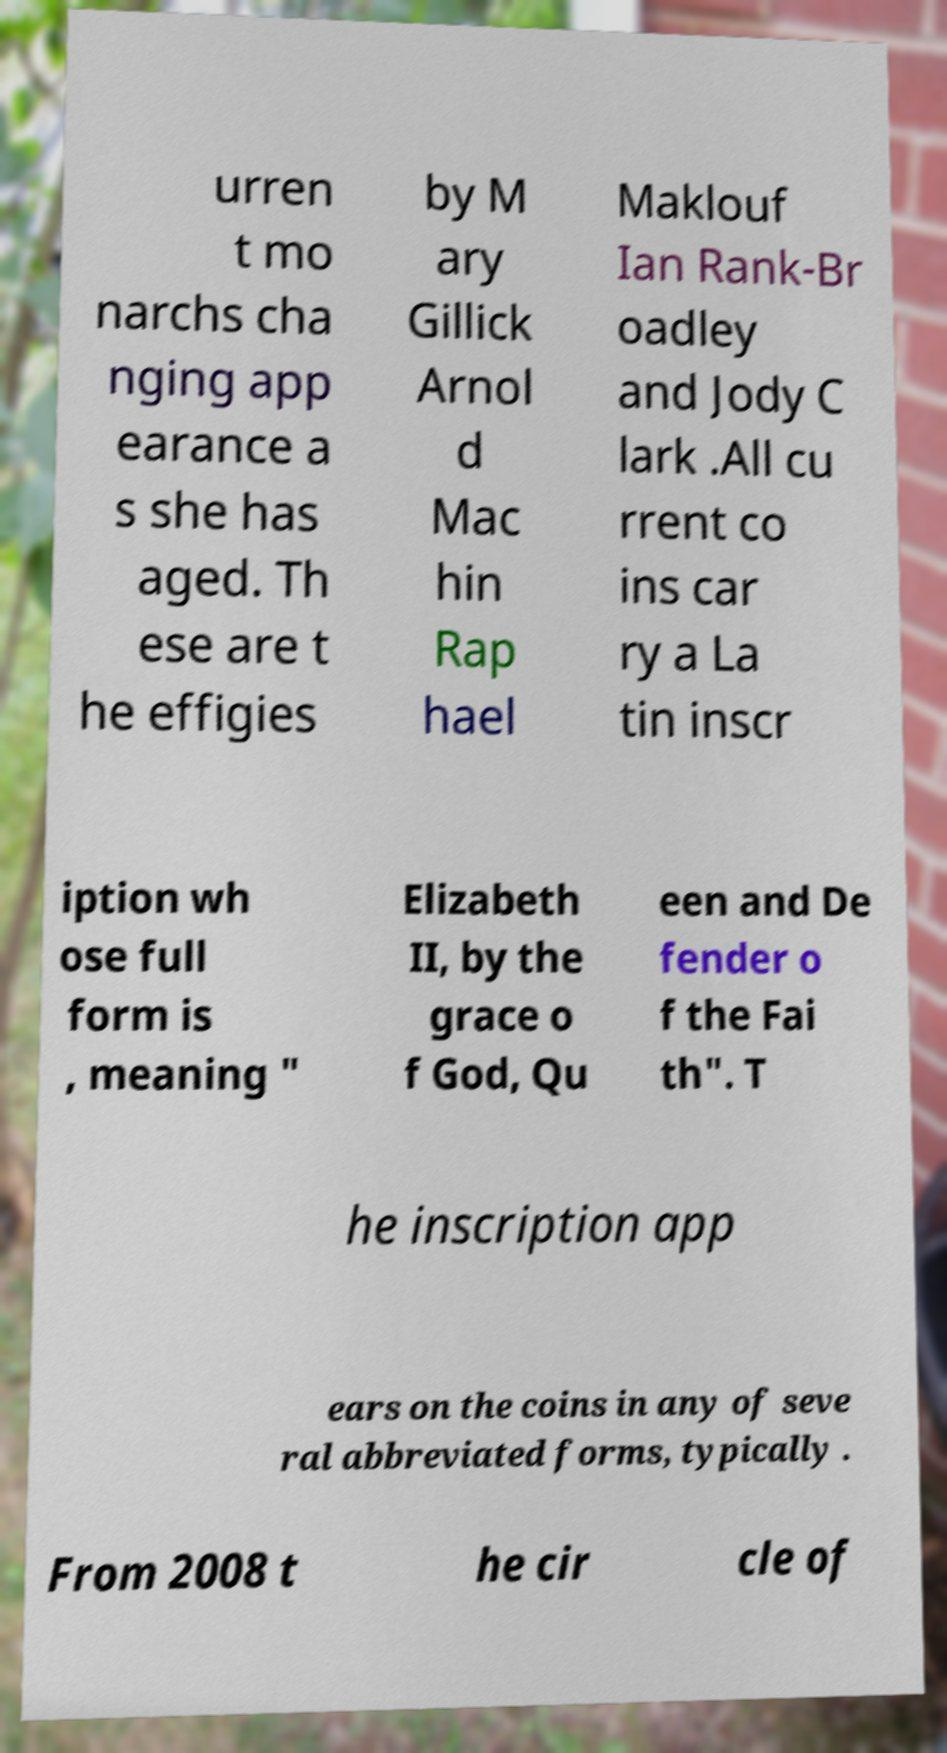Please read and relay the text visible in this image. What does it say? urren t mo narchs cha nging app earance a s she has aged. Th ese are t he effigies by M ary Gillick Arnol d Mac hin Rap hael Maklouf Ian Rank-Br oadley and Jody C lark .All cu rrent co ins car ry a La tin inscr iption wh ose full form is , meaning " Elizabeth II, by the grace o f God, Qu een and De fender o f the Fai th". T he inscription app ears on the coins in any of seve ral abbreviated forms, typically . From 2008 t he cir cle of 